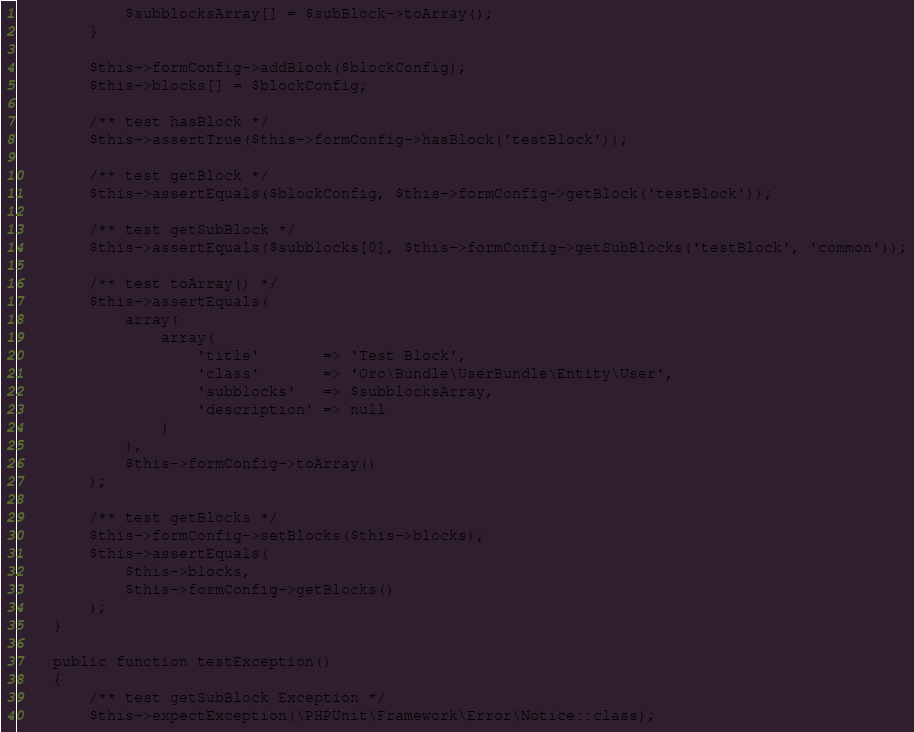Convert code to text. <code><loc_0><loc_0><loc_500><loc_500><_PHP_>            $subblocksArray[] = $subBlock->toArray();
        }

        $this->formConfig->addBlock($blockConfig);
        $this->blocks[] = $blockConfig;

        /** test hasBlock */
        $this->assertTrue($this->formConfig->hasBlock('testBlock'));

        /** test getBlock */
        $this->assertEquals($blockConfig, $this->formConfig->getBlock('testBlock'));

        /** test getSubBlock */
        $this->assertEquals($subblocks[0], $this->formConfig->getSubBlocks('testBlock', 'common'));

        /** test toArray() */
        $this->assertEquals(
            array(
                array(
                    'title'       => 'Test Block',
                    'class'       => 'Oro\Bundle\UserBundle\Entity\User',
                    'subblocks'   => $subblocksArray,
                    'description' => null
                )
            ),
            $this->formConfig->toArray()
        );

        /** test getBlocks */
        $this->formConfig->setBlocks($this->blocks);
        $this->assertEquals(
            $this->blocks,
            $this->formConfig->getBlocks()
        );
    }

    public function testException()
    {
        /** test getSubBlock Exception */
        $this->expectException(\PHPUnit\Framework\Error\Notice::class);</code> 